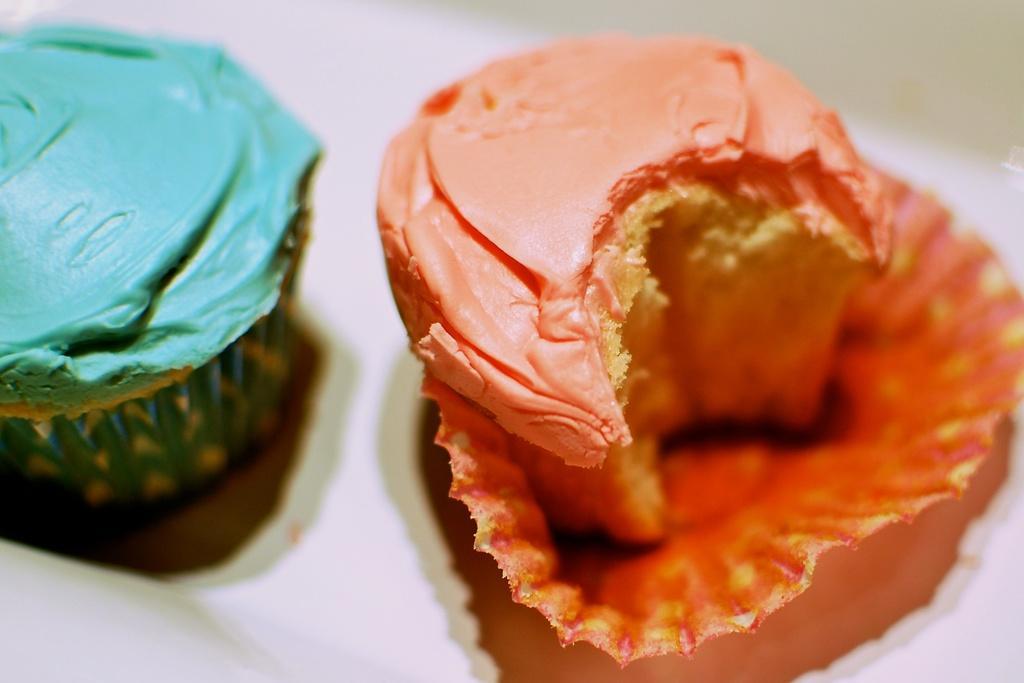Can you describe this image briefly? In the image we can see there are two cupcakes of different color. This is a cover. 